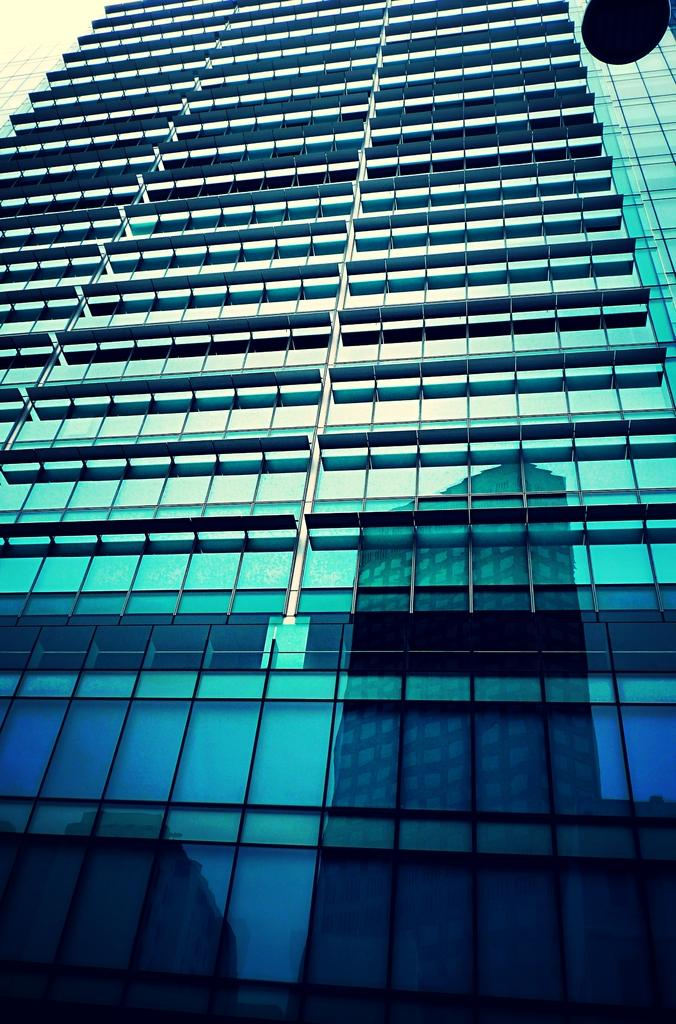What type of structure is present in the image? There is a building in the image. Can you describe any additional features related to the building? The reflection of the building is visible at the bottom of the image. What type of desk can be seen in the image? There is no desk present in the image; it only features a building and its reflection. Is the image taken during the night? The provided facts do not mention the time of day, so it cannot be determined if the image was taken during the night. 